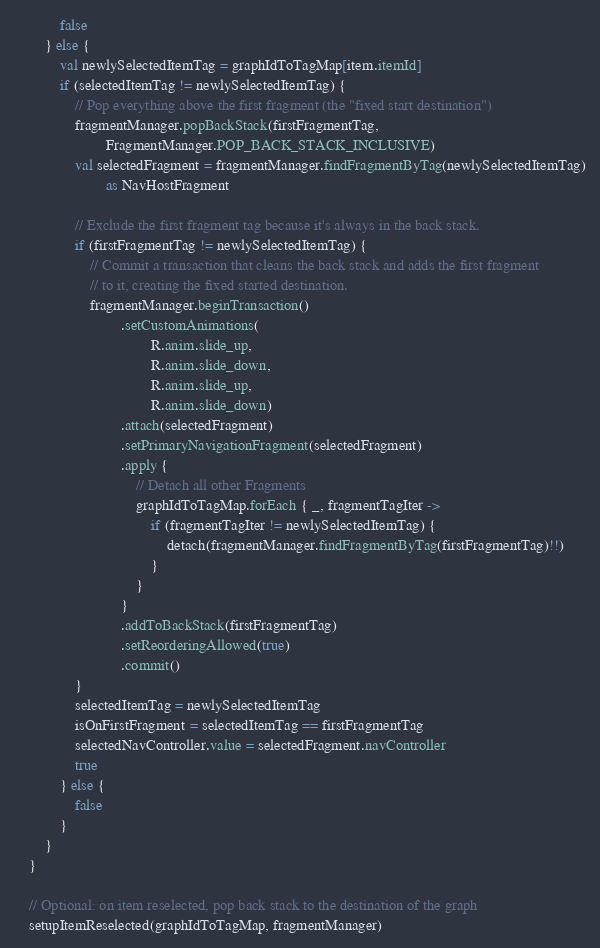<code> <loc_0><loc_0><loc_500><loc_500><_Kotlin_>            false
        } else {
            val newlySelectedItemTag = graphIdToTagMap[item.itemId]
            if (selectedItemTag != newlySelectedItemTag) {
                // Pop everything above the first fragment (the "fixed start destination")
                fragmentManager.popBackStack(firstFragmentTag,
                        FragmentManager.POP_BACK_STACK_INCLUSIVE)
                val selectedFragment = fragmentManager.findFragmentByTag(newlySelectedItemTag)
                        as NavHostFragment

                // Exclude the first fragment tag because it's always in the back stack.
                if (firstFragmentTag != newlySelectedItemTag) {
                    // Commit a transaction that cleans the back stack and adds the first fragment
                    // to it, creating the fixed started destination.
                    fragmentManager.beginTransaction()
                            .setCustomAnimations(
                                    R.anim.slide_up,
                                    R.anim.slide_down,
                                    R.anim.slide_up,
                                    R.anim.slide_down)
                            .attach(selectedFragment)
                            .setPrimaryNavigationFragment(selectedFragment)
                            .apply {
                                // Detach all other Fragments
                                graphIdToTagMap.forEach { _, fragmentTagIter ->
                                    if (fragmentTagIter != newlySelectedItemTag) {
                                        detach(fragmentManager.findFragmentByTag(firstFragmentTag)!!)
                                    }
                                }
                            }
                            .addToBackStack(firstFragmentTag)
                            .setReorderingAllowed(true)
                            .commit()
                }
                selectedItemTag = newlySelectedItemTag
                isOnFirstFragment = selectedItemTag == firstFragmentTag
                selectedNavController.value = selectedFragment.navController
                true
            } else {
                false
            }
        }
    }

    // Optional: on item reselected, pop back stack to the destination of the graph
    setupItemReselected(graphIdToTagMap, fragmentManager)
</code> 